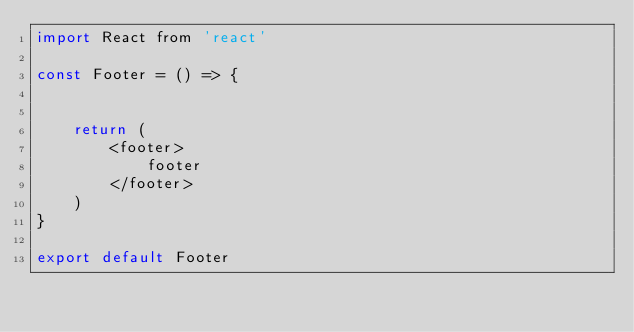Convert code to text. <code><loc_0><loc_0><loc_500><loc_500><_JavaScript_>import React from 'react'

const Footer = () => {


    return (
        <footer>
            footer
        </footer>
    )
}

export default Footer</code> 